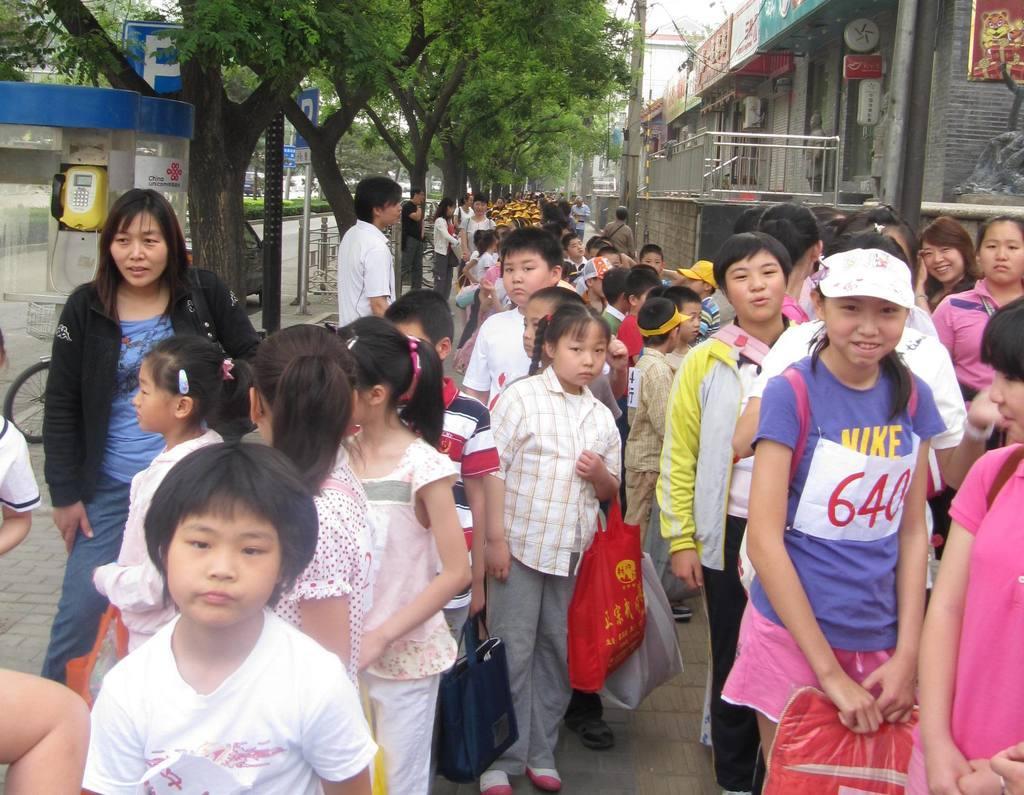In one or two sentences, can you explain what this image depicts? In this image I can see group of people standing. In front the person is wearing white color shirt. In the background I can see few stores, railing, few boards, trees in green color and the sky is in white color and I can also see the telephone. 